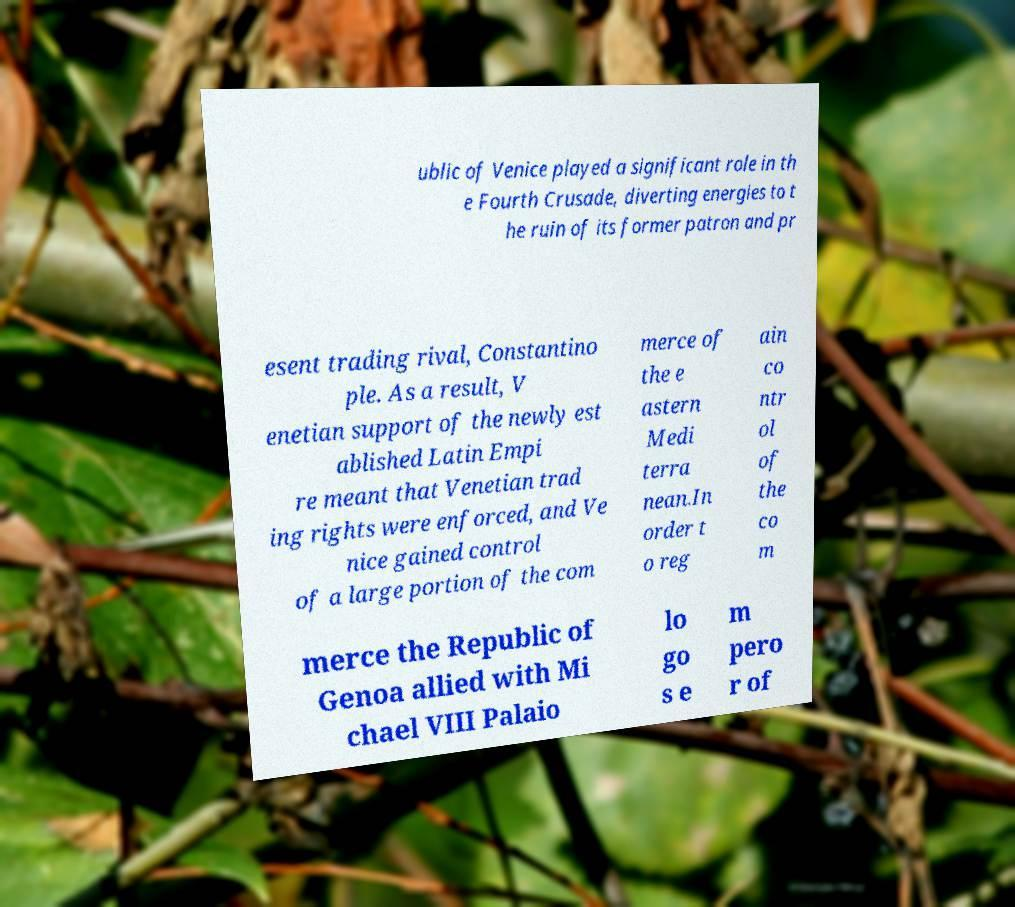Can you accurately transcribe the text from the provided image for me? ublic of Venice played a significant role in th e Fourth Crusade, diverting energies to t he ruin of its former patron and pr esent trading rival, Constantino ple. As a result, V enetian support of the newly est ablished Latin Empi re meant that Venetian trad ing rights were enforced, and Ve nice gained control of a large portion of the com merce of the e astern Medi terra nean.In order t o reg ain co ntr ol of the co m merce the Republic of Genoa allied with Mi chael VIII Palaio lo go s e m pero r of 